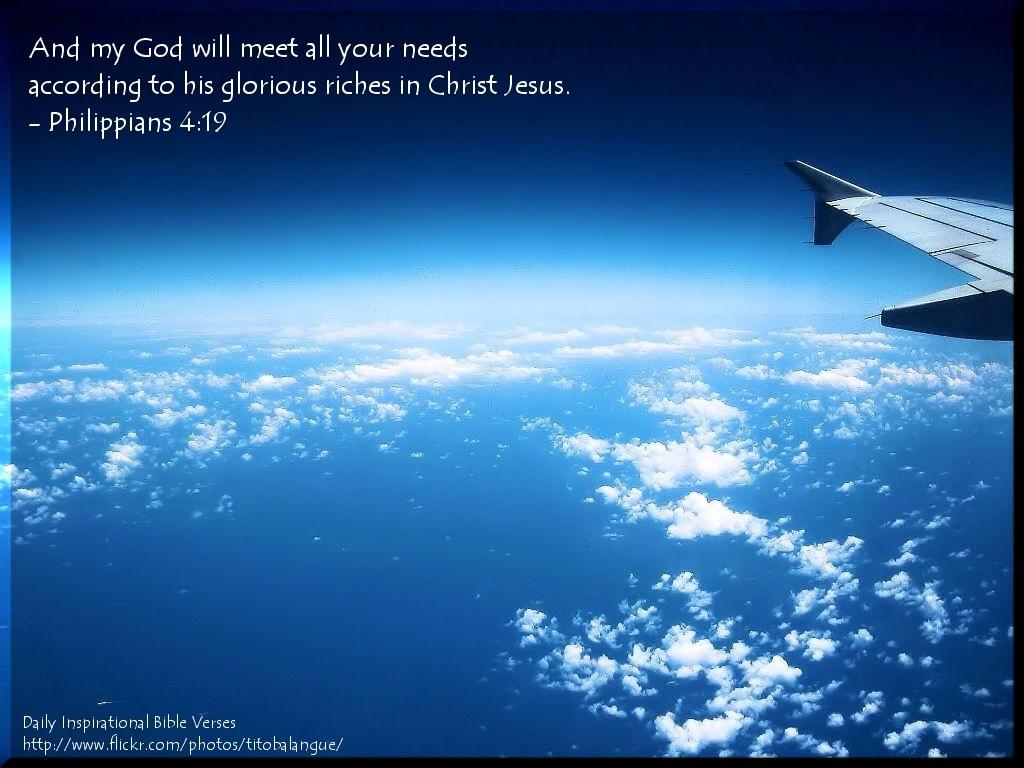Provide a one-sentence caption for the provided image. An inspirational poster of an airplane flying above clouds with a Bible verse from Philippians 4:19. 